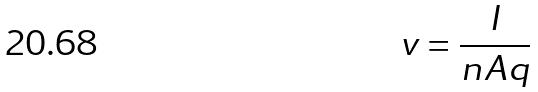<formula> <loc_0><loc_0><loc_500><loc_500>v = \frac { I } { n A q }</formula> 